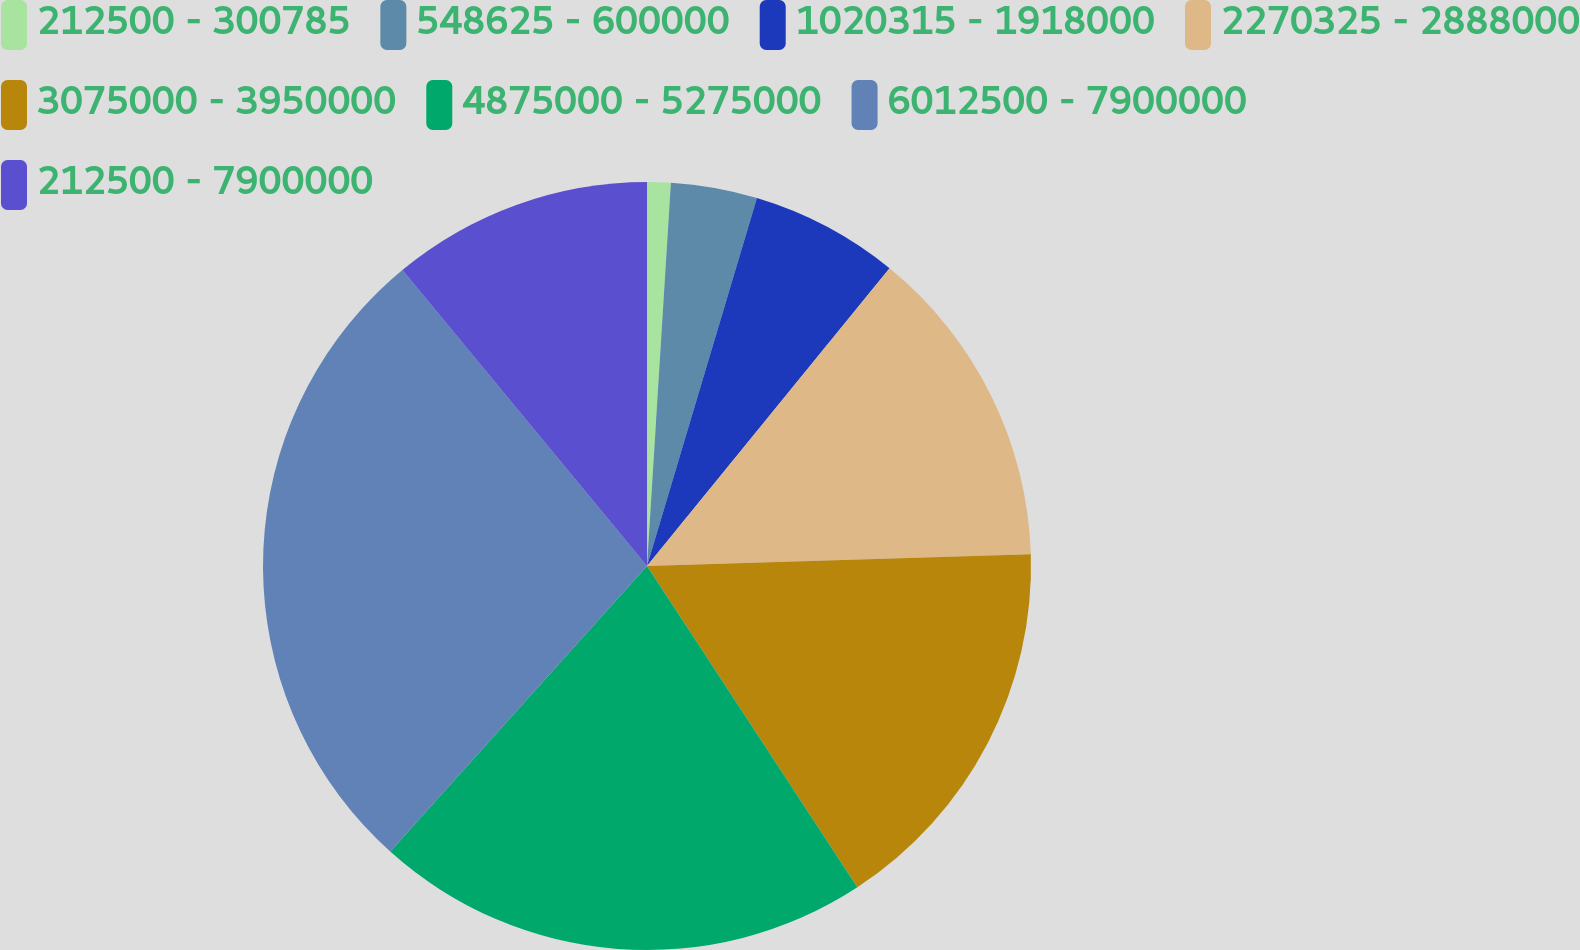<chart> <loc_0><loc_0><loc_500><loc_500><pie_chart><fcel>212500 - 300785<fcel>548625 - 600000<fcel>1020315 - 1918000<fcel>2270325 - 2888000<fcel>3075000 - 3950000<fcel>4875000 - 5275000<fcel>6012500 - 7900000<fcel>212500 - 7900000<nl><fcel>0.99%<fcel>3.63%<fcel>6.26%<fcel>13.63%<fcel>16.26%<fcel>20.88%<fcel>27.35%<fcel>10.99%<nl></chart> 